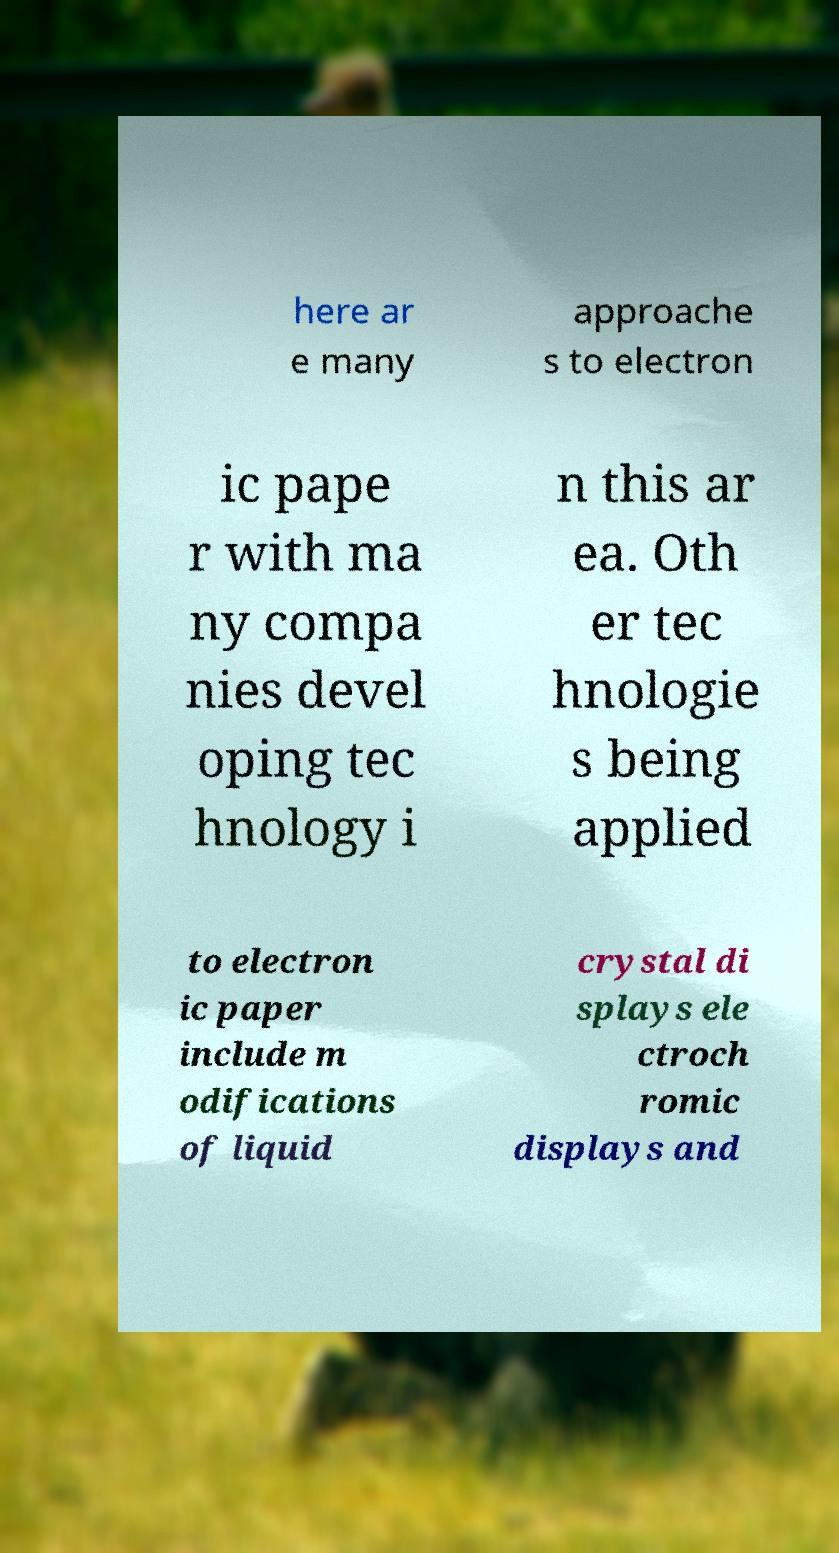Please read and relay the text visible in this image. What does it say? here ar e many approache s to electron ic pape r with ma ny compa nies devel oping tec hnology i n this ar ea. Oth er tec hnologie s being applied to electron ic paper include m odifications of liquid crystal di splays ele ctroch romic displays and 